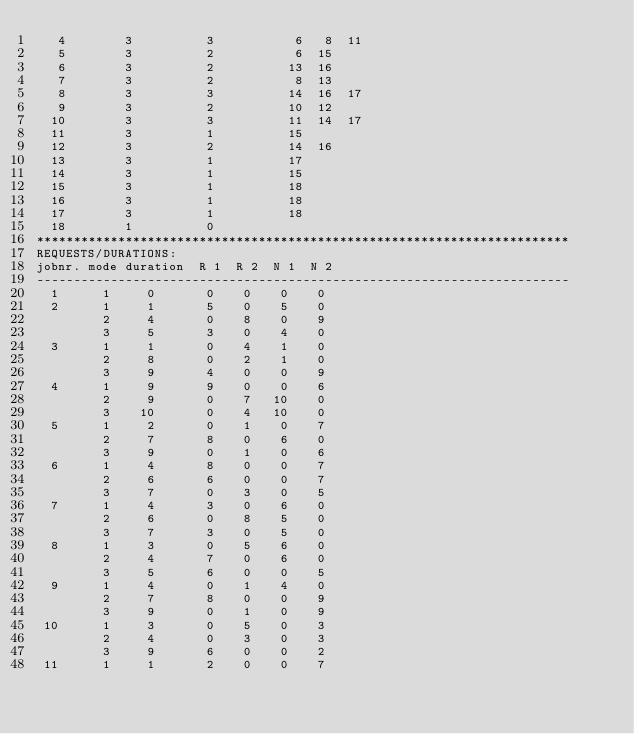<code> <loc_0><loc_0><loc_500><loc_500><_ObjectiveC_>   4        3          3           6   8  11
   5        3          2           6  15
   6        3          2          13  16
   7        3          2           8  13
   8        3          3          14  16  17
   9        3          2          10  12
  10        3          3          11  14  17
  11        3          1          15
  12        3          2          14  16
  13        3          1          17
  14        3          1          15
  15        3          1          18
  16        3          1          18
  17        3          1          18
  18        1          0        
************************************************************************
REQUESTS/DURATIONS:
jobnr. mode duration  R 1  R 2  N 1  N 2
------------------------------------------------------------------------
  1      1     0       0    0    0    0
  2      1     1       5    0    5    0
         2     4       0    8    0    9
         3     5       3    0    4    0
  3      1     1       0    4    1    0
         2     8       0    2    1    0
         3     9       4    0    0    9
  4      1     9       9    0    0    6
         2     9       0    7   10    0
         3    10       0    4   10    0
  5      1     2       0    1    0    7
         2     7       8    0    6    0
         3     9       0    1    0    6
  6      1     4       8    0    0    7
         2     6       6    0    0    7
         3     7       0    3    0    5
  7      1     4       3    0    6    0
         2     6       0    8    5    0
         3     7       3    0    5    0
  8      1     3       0    5    6    0
         2     4       7    0    6    0
         3     5       6    0    0    5
  9      1     4       0    1    4    0
         2     7       8    0    0    9
         3     9       0    1    0    9
 10      1     3       0    5    0    3
         2     4       0    3    0    3
         3     9       6    0    0    2
 11      1     1       2    0    0    7</code> 